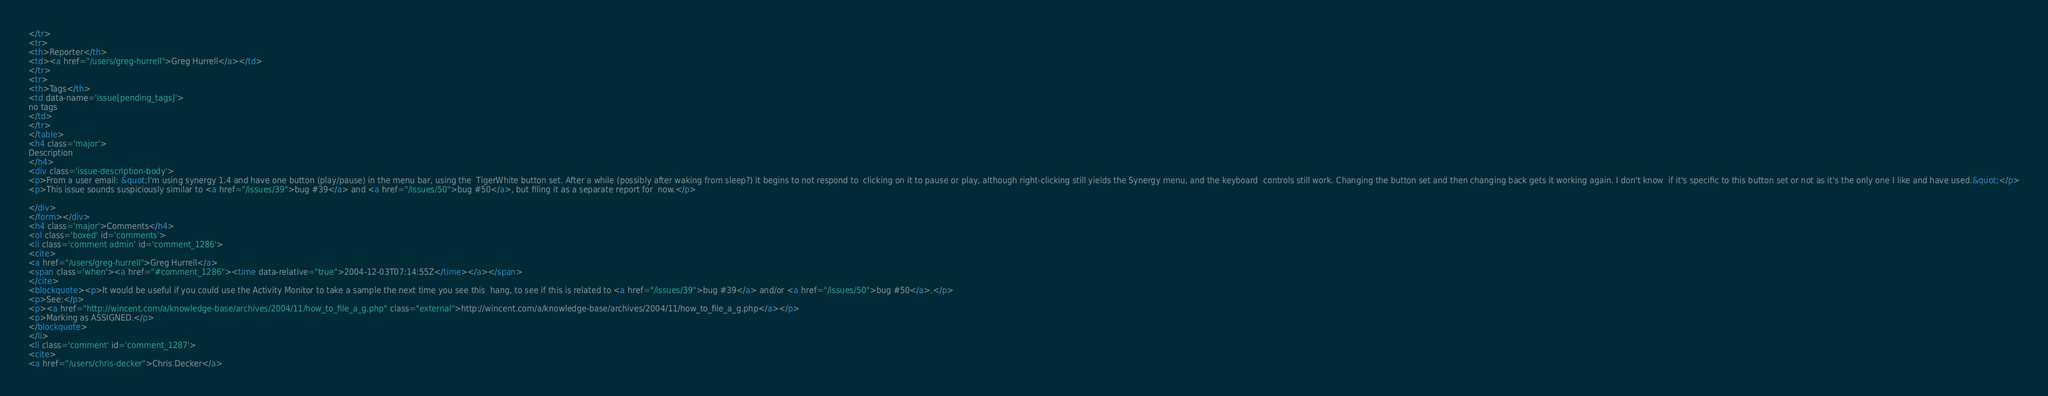Convert code to text. <code><loc_0><loc_0><loc_500><loc_500><_HTML_></tr>
<tr>
<th>Reporter</th>
<td><a href="/users/greg-hurrell">Greg Hurrell</a></td>
</tr>
<tr>
<th>Tags</th>
<td data-name='issue[pending_tags]'>
no tags
</td>
</tr>
</table>
<h4 class='major'>
Description
</h4>
<div class='issue-description-body'>
<p>From a user email: &quot;I'm using synergy 1.4 and have one button (play/pause) in the menu bar, using the  TigerWhite button set. After a while (possibly after waking from sleep?) it begins to not respond to  clicking on it to pause or play, although right-clicking still yields the Synergy menu, and the keyboard  controls still work. Changing the button set and then changing back gets it working again. I don't know  if it's specific to this button set or not as it's the only one I like and have used.&quot;</p>
<p>This issue sounds suspiciously similar to <a href="/issues/39">bug #39</a> and <a href="/issues/50">bug #50</a>, but filing it as a separate report for  now.</p>

</div>
</form></div>
<h4 class='major'>Comments</h4>
<ol class='boxed' id='comments'>
<li class='comment admin' id='comment_1286'>
<cite>
<a href="/users/greg-hurrell">Greg Hurrell</a>
<span class='when'><a href="#comment_1286"><time data-relative="true">2004-12-03T07:14:55Z</time></a></span>
</cite>
<blockquote><p>It would be useful if you could use the Activity Monitor to take a sample the next time you see this  hang, to see if this is related to <a href="/issues/39">bug #39</a> and/or <a href="/issues/50">bug #50</a>.</p>
<p>See:</p>
<p><a href="http://wincent.com/a/knowledge-base/archives/2004/11/how_to_file_a_g.php" class="external">http://wincent.com/a/knowledge-base/archives/2004/11/how_to_file_a_g.php</a></p>
<p>Marking as ASSIGNED.</p>
</blockquote>
</li>
<li class='comment' id='comment_1287'>
<cite>
<a href="/users/chris-decker">Chris Decker</a></code> 